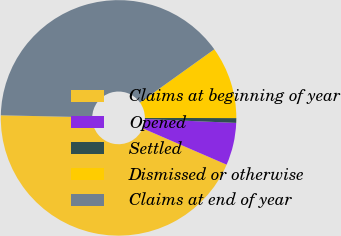Convert chart to OTSL. <chart><loc_0><loc_0><loc_500><loc_500><pie_chart><fcel>Claims at beginning of year<fcel>Opened<fcel>Settled<fcel>Dismissed or otherwise<fcel>Claims at end of year<nl><fcel>43.85%<fcel>5.82%<fcel>0.65%<fcel>9.92%<fcel>39.76%<nl></chart> 